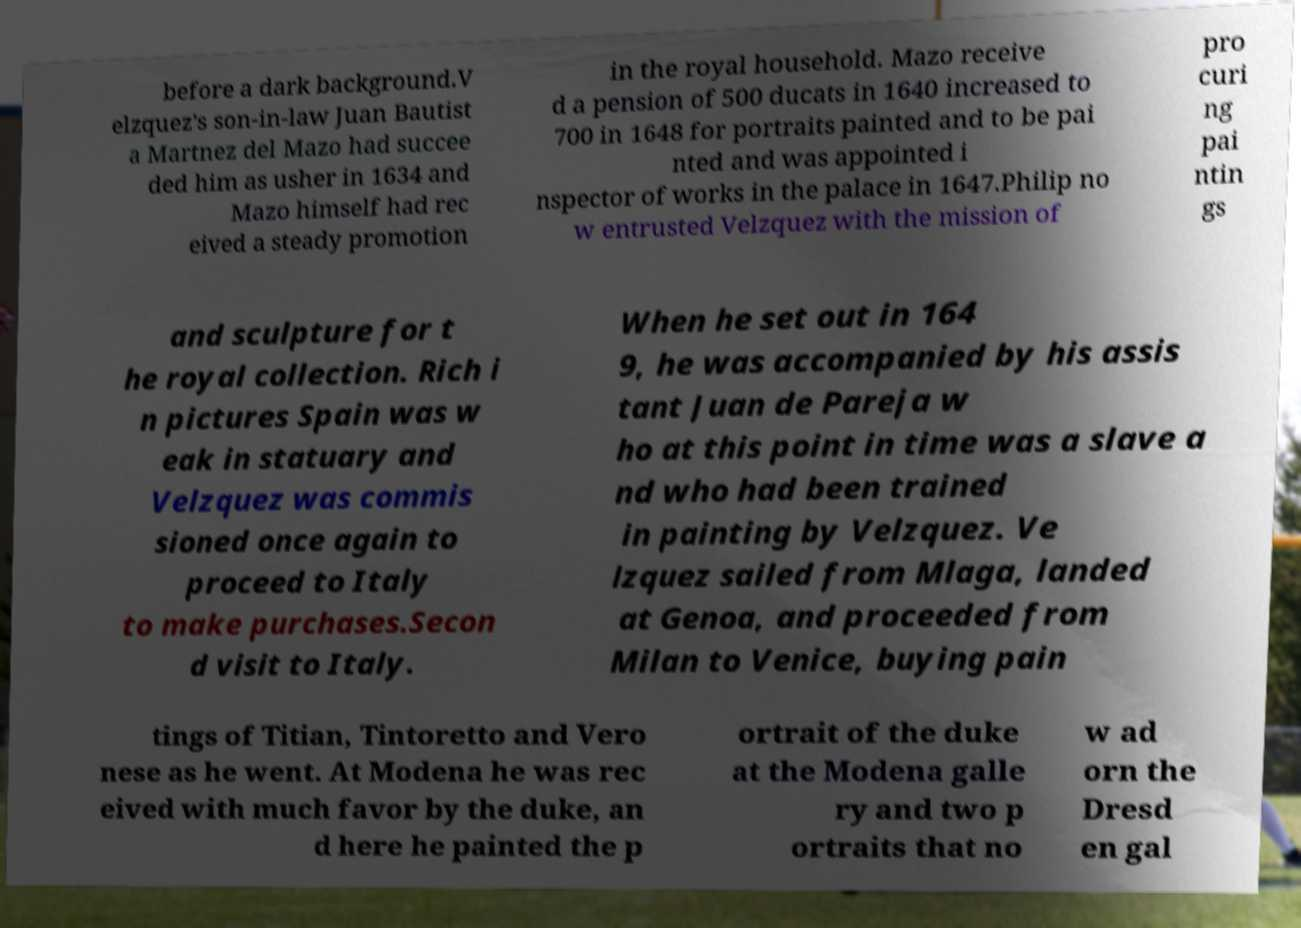Could you assist in decoding the text presented in this image and type it out clearly? before a dark background.V elzquez's son-in-law Juan Bautist a Martnez del Mazo had succee ded him as usher in 1634 and Mazo himself had rec eived a steady promotion in the royal household. Mazo receive d a pension of 500 ducats in 1640 increased to 700 in 1648 for portraits painted and to be pai nted and was appointed i nspector of works in the palace in 1647.Philip no w entrusted Velzquez with the mission of pro curi ng pai ntin gs and sculpture for t he royal collection. Rich i n pictures Spain was w eak in statuary and Velzquez was commis sioned once again to proceed to Italy to make purchases.Secon d visit to Italy. When he set out in 164 9, he was accompanied by his assis tant Juan de Pareja w ho at this point in time was a slave a nd who had been trained in painting by Velzquez. Ve lzquez sailed from Mlaga, landed at Genoa, and proceeded from Milan to Venice, buying pain tings of Titian, Tintoretto and Vero nese as he went. At Modena he was rec eived with much favor by the duke, an d here he painted the p ortrait of the duke at the Modena galle ry and two p ortraits that no w ad orn the Dresd en gal 